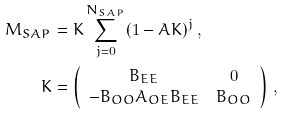<formula> <loc_0><loc_0><loc_500><loc_500>M _ { S A P } & = K \sum _ { j = 0 } ^ { N _ { S A P } } ( 1 - A K ) ^ { j } \, , \\ K & = \left ( \begin{array} { c c } B _ { E E } & 0 \\ - B _ { O O } A _ { O E } B _ { E E } & B _ { O O } \\ \end{array} \right ) \, , \\</formula> 